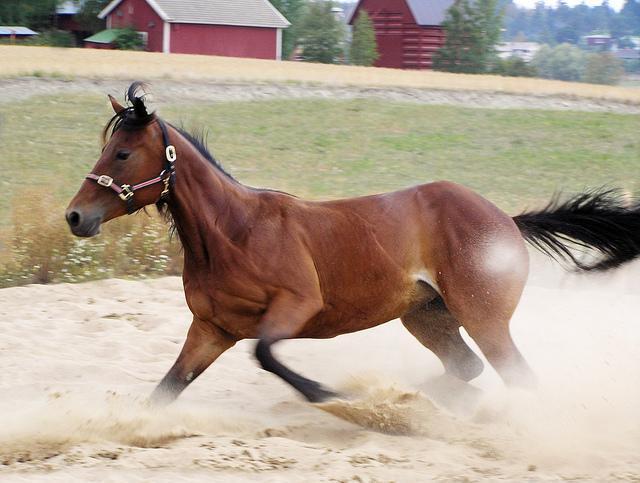How many red buildings are there?
Give a very brief answer. 2. 